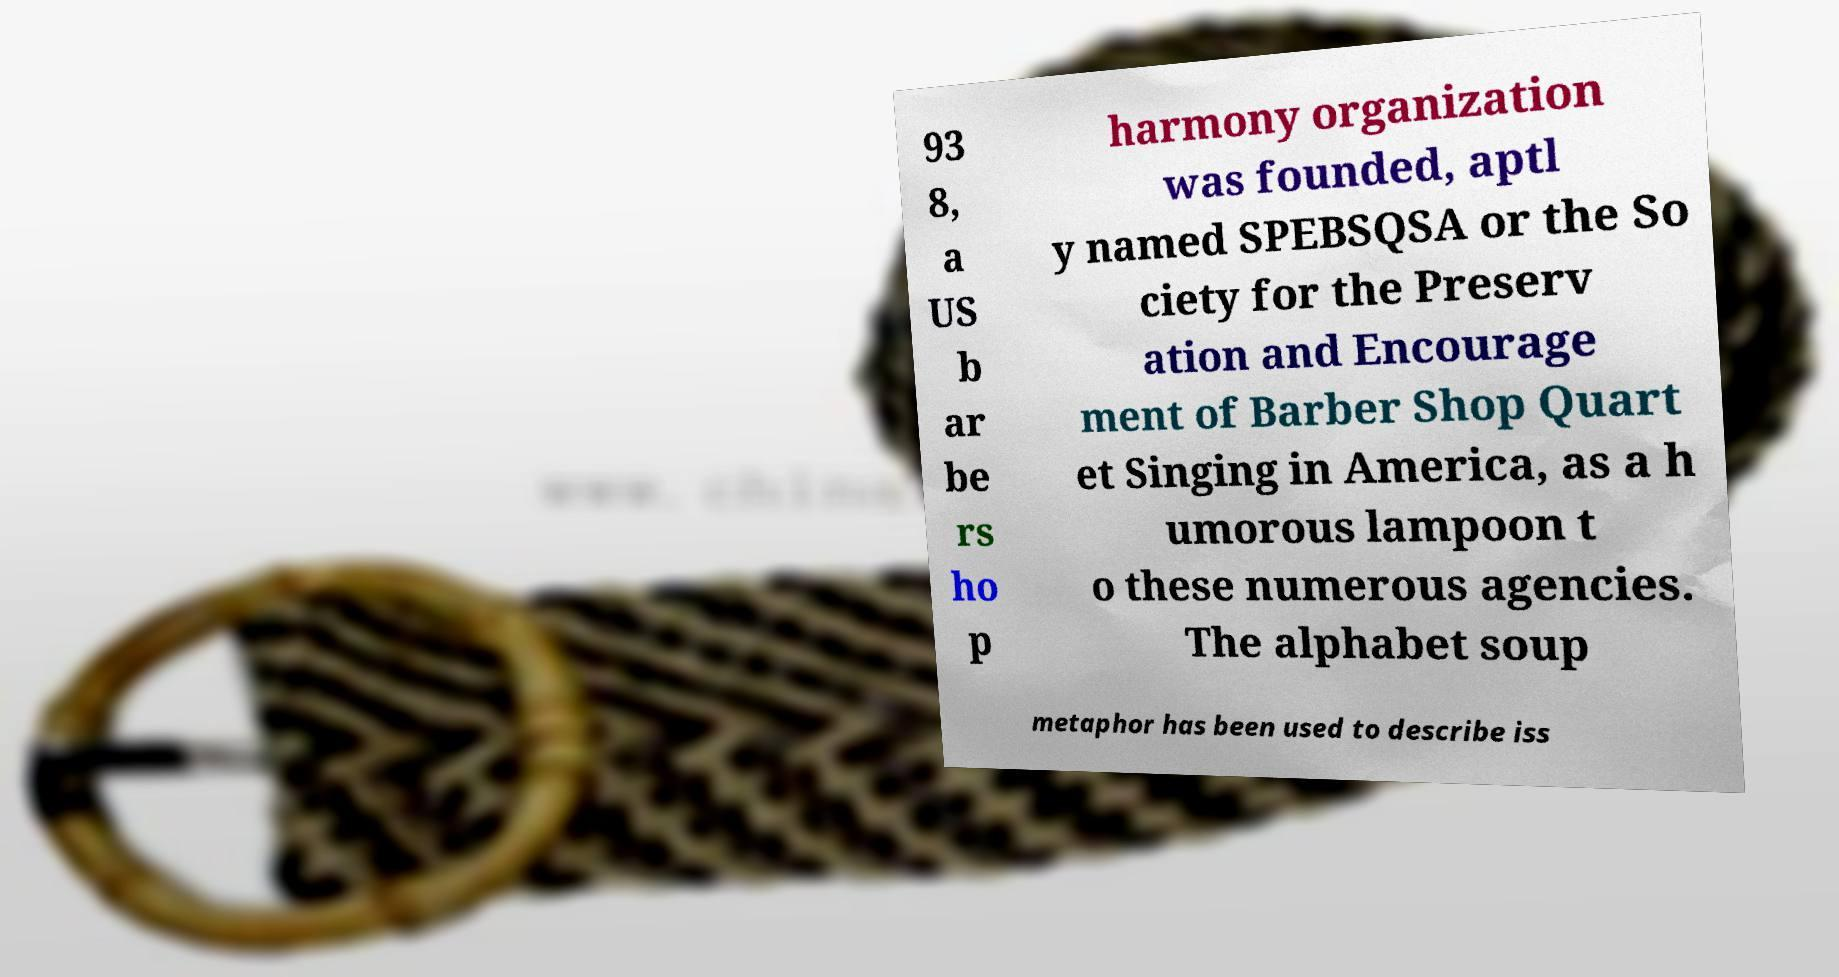Could you assist in decoding the text presented in this image and type it out clearly? 93 8, a US b ar be rs ho p harmony organization was founded, aptl y named SPEBSQSA or the So ciety for the Preserv ation and Encourage ment of Barber Shop Quart et Singing in America, as a h umorous lampoon t o these numerous agencies. The alphabet soup metaphor has been used to describe iss 